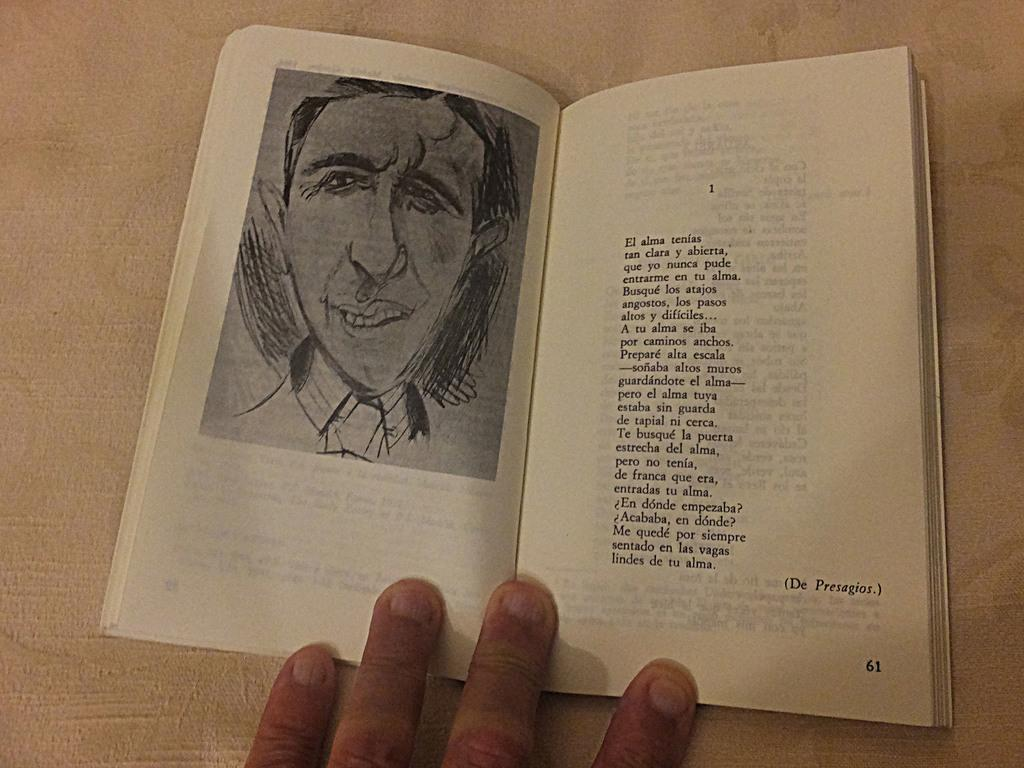What is the main subject in the center of the image? There is a book in the center of the image. What can be seen on the book? The book has text and an image on it. Is there any indication of someone interacting with the book? Yes, there is a hand at the bottom side of the book. What type of carriage is being used by the manager in the image? There is no carriage or manager present in the image; it features a book with a hand at the bottom side. What is the person's interest in the book, as seen in the image? The image does not provide any information about the person's interest in the book. 